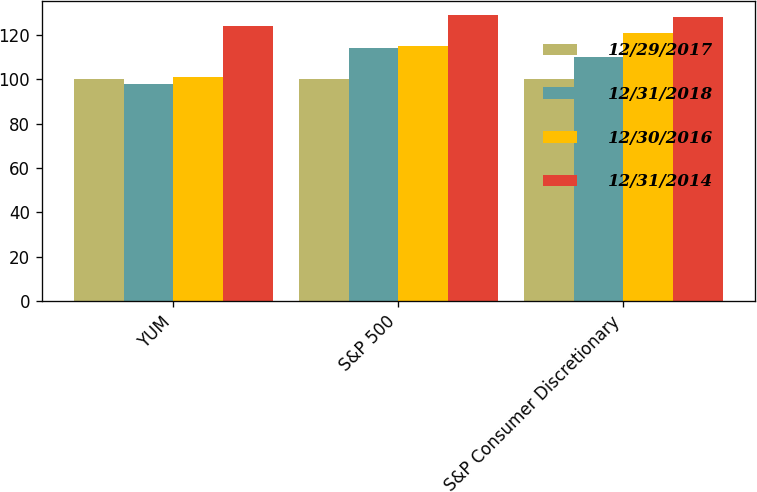Convert chart to OTSL. <chart><loc_0><loc_0><loc_500><loc_500><stacked_bar_chart><ecel><fcel>YUM<fcel>S&P 500<fcel>S&P Consumer Discretionary<nl><fcel>12/29/2017<fcel>100<fcel>100<fcel>100<nl><fcel>12/31/2018<fcel>98<fcel>114<fcel>110<nl><fcel>12/30/2016<fcel>101<fcel>115<fcel>121<nl><fcel>12/31/2014<fcel>124<fcel>129<fcel>128<nl></chart> 